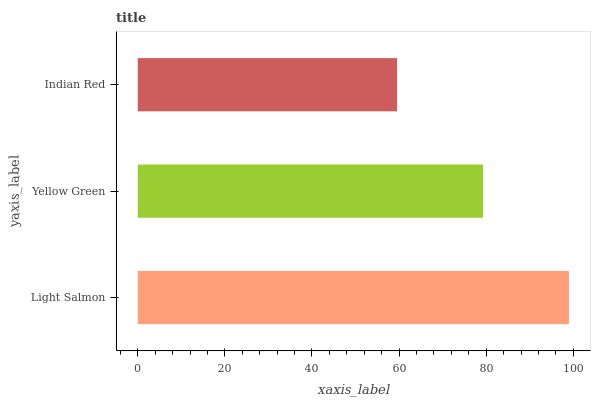Is Indian Red the minimum?
Answer yes or no. Yes. Is Light Salmon the maximum?
Answer yes or no. Yes. Is Yellow Green the minimum?
Answer yes or no. No. Is Yellow Green the maximum?
Answer yes or no. No. Is Light Salmon greater than Yellow Green?
Answer yes or no. Yes. Is Yellow Green less than Light Salmon?
Answer yes or no. Yes. Is Yellow Green greater than Light Salmon?
Answer yes or no. No. Is Light Salmon less than Yellow Green?
Answer yes or no. No. Is Yellow Green the high median?
Answer yes or no. Yes. Is Yellow Green the low median?
Answer yes or no. Yes. Is Light Salmon the high median?
Answer yes or no. No. Is Light Salmon the low median?
Answer yes or no. No. 